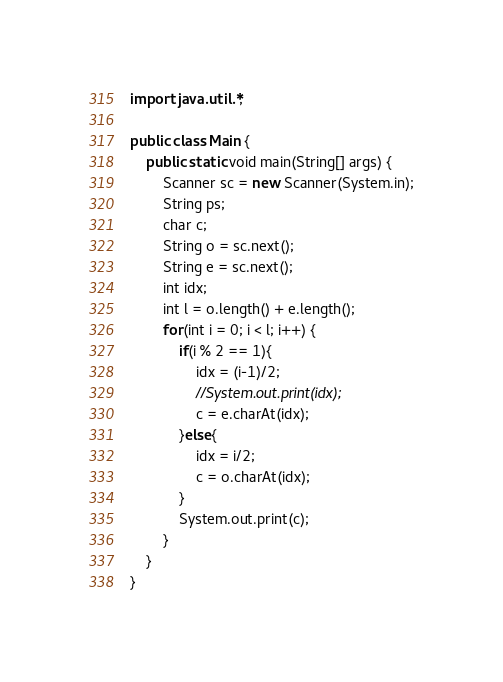Convert code to text. <code><loc_0><loc_0><loc_500><loc_500><_Java_>
import java.util.*;

public class Main {
	public static void main(String[] args) {
		Scanner sc = new Scanner(System.in);
		String ps;
		char c;
		String o = sc.next();
		String e = sc.next();
		int idx;
		int l = o.length() + e.length();
		for(int i = 0; i < l; i++) {
			if(i % 2 == 1){
				idx = (i-1)/2;
				//System.out.print(idx);
				c = e.charAt(idx);
			}else{
				idx = i/2;
				c = o.charAt(idx);
			}
			System.out.print(c);
		}
	}
}
</code> 